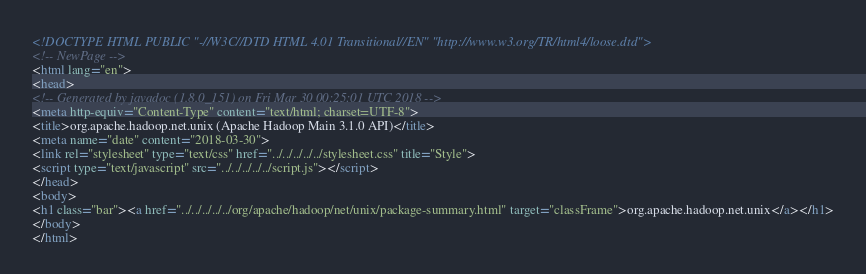<code> <loc_0><loc_0><loc_500><loc_500><_HTML_><!DOCTYPE HTML PUBLIC "-//W3C//DTD HTML 4.01 Transitional//EN" "http://www.w3.org/TR/html4/loose.dtd">
<!-- NewPage -->
<html lang="en">
<head>
<!-- Generated by javadoc (1.8.0_151) on Fri Mar 30 00:25:01 UTC 2018 -->
<meta http-equiv="Content-Type" content="text/html; charset=UTF-8">
<title>org.apache.hadoop.net.unix (Apache Hadoop Main 3.1.0 API)</title>
<meta name="date" content="2018-03-30">
<link rel="stylesheet" type="text/css" href="../../../../../stylesheet.css" title="Style">
<script type="text/javascript" src="../../../../../script.js"></script>
</head>
<body>
<h1 class="bar"><a href="../../../../../org/apache/hadoop/net/unix/package-summary.html" target="classFrame">org.apache.hadoop.net.unix</a></h1>
</body>
</html>
</code> 